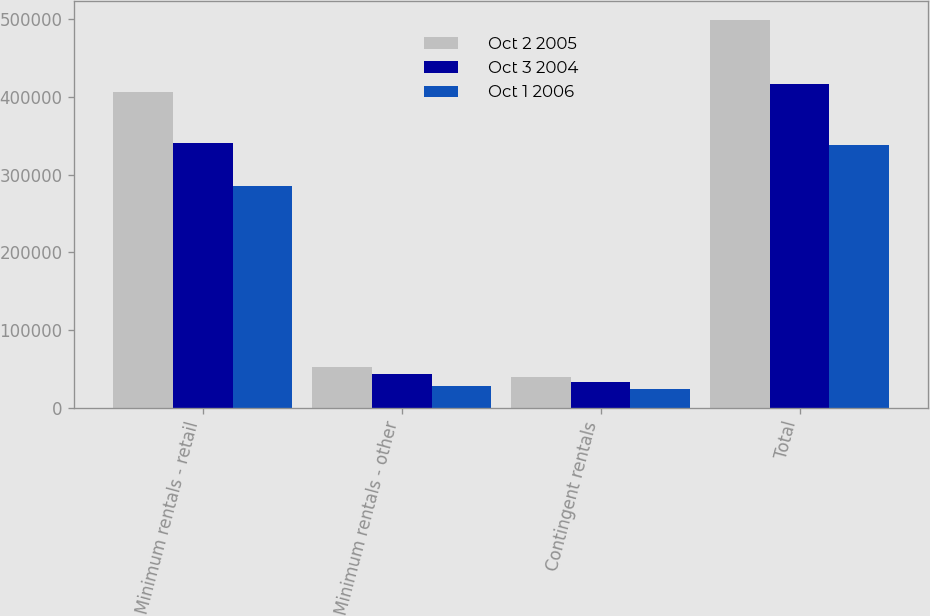Convert chart. <chart><loc_0><loc_0><loc_500><loc_500><stacked_bar_chart><ecel><fcel>Minimum rentals - retail<fcel>Minimum rentals - other<fcel>Contingent rentals<fcel>Total<nl><fcel>Oct 2 2005<fcel>406329<fcel>52367<fcel>40113<fcel>498809<nl><fcel>Oct 3 2004<fcel>340474<fcel>43532<fcel>32910<fcel>416916<nl><fcel>Oct 1 2006<fcel>285250<fcel>28108<fcel>24638<fcel>337996<nl></chart> 